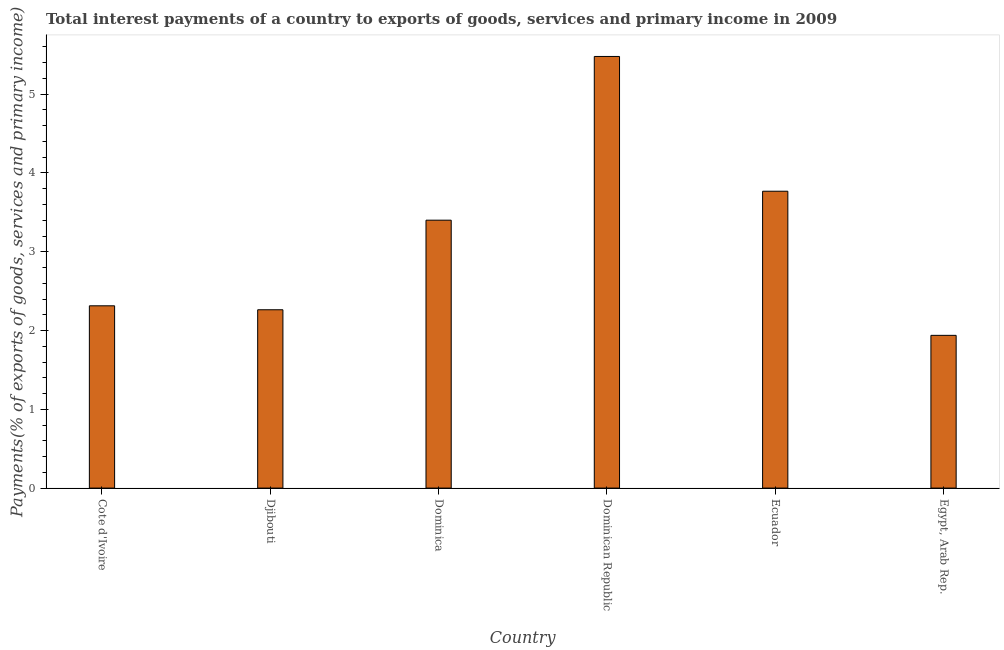What is the title of the graph?
Provide a succinct answer. Total interest payments of a country to exports of goods, services and primary income in 2009. What is the label or title of the X-axis?
Your response must be concise. Country. What is the label or title of the Y-axis?
Offer a terse response. Payments(% of exports of goods, services and primary income). What is the total interest payments on external debt in Dominican Republic?
Make the answer very short. 5.48. Across all countries, what is the maximum total interest payments on external debt?
Provide a short and direct response. 5.48. Across all countries, what is the minimum total interest payments on external debt?
Keep it short and to the point. 1.94. In which country was the total interest payments on external debt maximum?
Offer a terse response. Dominican Republic. In which country was the total interest payments on external debt minimum?
Offer a terse response. Egypt, Arab Rep. What is the sum of the total interest payments on external debt?
Provide a short and direct response. 19.17. What is the difference between the total interest payments on external debt in Djibouti and Dominica?
Offer a terse response. -1.14. What is the average total interest payments on external debt per country?
Offer a very short reply. 3.19. What is the median total interest payments on external debt?
Keep it short and to the point. 2.86. What is the ratio of the total interest payments on external debt in Djibouti to that in Egypt, Arab Rep.?
Offer a terse response. 1.17. What is the difference between the highest and the second highest total interest payments on external debt?
Ensure brevity in your answer.  1.71. Is the sum of the total interest payments on external debt in Djibouti and Ecuador greater than the maximum total interest payments on external debt across all countries?
Offer a very short reply. Yes. What is the difference between the highest and the lowest total interest payments on external debt?
Keep it short and to the point. 3.54. Are all the bars in the graph horizontal?
Offer a very short reply. No. What is the Payments(% of exports of goods, services and primary income) of Cote d'Ivoire?
Provide a succinct answer. 2.31. What is the Payments(% of exports of goods, services and primary income) of Djibouti?
Your response must be concise. 2.26. What is the Payments(% of exports of goods, services and primary income) of Dominica?
Your answer should be very brief. 3.4. What is the Payments(% of exports of goods, services and primary income) in Dominican Republic?
Ensure brevity in your answer.  5.48. What is the Payments(% of exports of goods, services and primary income) of Ecuador?
Keep it short and to the point. 3.77. What is the Payments(% of exports of goods, services and primary income) of Egypt, Arab Rep.?
Provide a succinct answer. 1.94. What is the difference between the Payments(% of exports of goods, services and primary income) in Cote d'Ivoire and Djibouti?
Your answer should be compact. 0.05. What is the difference between the Payments(% of exports of goods, services and primary income) in Cote d'Ivoire and Dominica?
Offer a very short reply. -1.09. What is the difference between the Payments(% of exports of goods, services and primary income) in Cote d'Ivoire and Dominican Republic?
Provide a short and direct response. -3.17. What is the difference between the Payments(% of exports of goods, services and primary income) in Cote d'Ivoire and Ecuador?
Provide a succinct answer. -1.45. What is the difference between the Payments(% of exports of goods, services and primary income) in Cote d'Ivoire and Egypt, Arab Rep.?
Your answer should be very brief. 0.38. What is the difference between the Payments(% of exports of goods, services and primary income) in Djibouti and Dominica?
Your response must be concise. -1.14. What is the difference between the Payments(% of exports of goods, services and primary income) in Djibouti and Dominican Republic?
Your answer should be very brief. -3.22. What is the difference between the Payments(% of exports of goods, services and primary income) in Djibouti and Ecuador?
Ensure brevity in your answer.  -1.5. What is the difference between the Payments(% of exports of goods, services and primary income) in Djibouti and Egypt, Arab Rep.?
Provide a short and direct response. 0.32. What is the difference between the Payments(% of exports of goods, services and primary income) in Dominica and Dominican Republic?
Ensure brevity in your answer.  -2.08. What is the difference between the Payments(% of exports of goods, services and primary income) in Dominica and Ecuador?
Offer a terse response. -0.37. What is the difference between the Payments(% of exports of goods, services and primary income) in Dominica and Egypt, Arab Rep.?
Provide a short and direct response. 1.46. What is the difference between the Payments(% of exports of goods, services and primary income) in Dominican Republic and Ecuador?
Offer a terse response. 1.71. What is the difference between the Payments(% of exports of goods, services and primary income) in Dominican Republic and Egypt, Arab Rep.?
Your response must be concise. 3.54. What is the difference between the Payments(% of exports of goods, services and primary income) in Ecuador and Egypt, Arab Rep.?
Keep it short and to the point. 1.83. What is the ratio of the Payments(% of exports of goods, services and primary income) in Cote d'Ivoire to that in Dominica?
Make the answer very short. 0.68. What is the ratio of the Payments(% of exports of goods, services and primary income) in Cote d'Ivoire to that in Dominican Republic?
Keep it short and to the point. 0.42. What is the ratio of the Payments(% of exports of goods, services and primary income) in Cote d'Ivoire to that in Ecuador?
Provide a short and direct response. 0.61. What is the ratio of the Payments(% of exports of goods, services and primary income) in Cote d'Ivoire to that in Egypt, Arab Rep.?
Your answer should be very brief. 1.19. What is the ratio of the Payments(% of exports of goods, services and primary income) in Djibouti to that in Dominica?
Make the answer very short. 0.67. What is the ratio of the Payments(% of exports of goods, services and primary income) in Djibouti to that in Dominican Republic?
Make the answer very short. 0.41. What is the ratio of the Payments(% of exports of goods, services and primary income) in Djibouti to that in Ecuador?
Offer a terse response. 0.6. What is the ratio of the Payments(% of exports of goods, services and primary income) in Djibouti to that in Egypt, Arab Rep.?
Make the answer very short. 1.17. What is the ratio of the Payments(% of exports of goods, services and primary income) in Dominica to that in Dominican Republic?
Offer a terse response. 0.62. What is the ratio of the Payments(% of exports of goods, services and primary income) in Dominica to that in Ecuador?
Offer a very short reply. 0.9. What is the ratio of the Payments(% of exports of goods, services and primary income) in Dominica to that in Egypt, Arab Rep.?
Provide a short and direct response. 1.75. What is the ratio of the Payments(% of exports of goods, services and primary income) in Dominican Republic to that in Ecuador?
Your response must be concise. 1.45. What is the ratio of the Payments(% of exports of goods, services and primary income) in Dominican Republic to that in Egypt, Arab Rep.?
Make the answer very short. 2.83. What is the ratio of the Payments(% of exports of goods, services and primary income) in Ecuador to that in Egypt, Arab Rep.?
Provide a succinct answer. 1.94. 